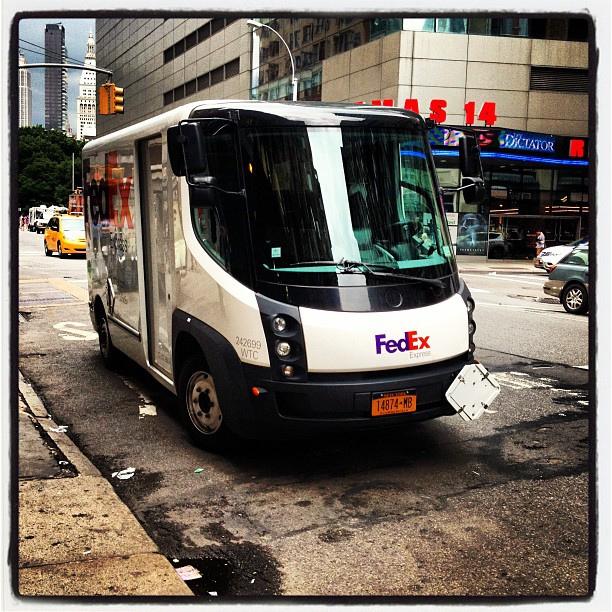What delivery service operates this vehicle?
Be succinct. Fedex. Is this truck parked?
Be succinct. Yes. What shape is the white object on the truck?
Keep it brief. Square. 